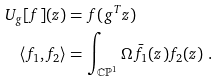<formula> <loc_0><loc_0><loc_500><loc_500>U _ { g } [ f ] ( z ) & = f ( g ^ { T } z ) \\ \left < f _ { 1 } , f _ { 2 } \right > & = \int _ { \mathbb { C P } ^ { 1 } } \Omega \, \bar { f } _ { 1 } ( z ) f _ { 2 } ( z ) \ .</formula> 